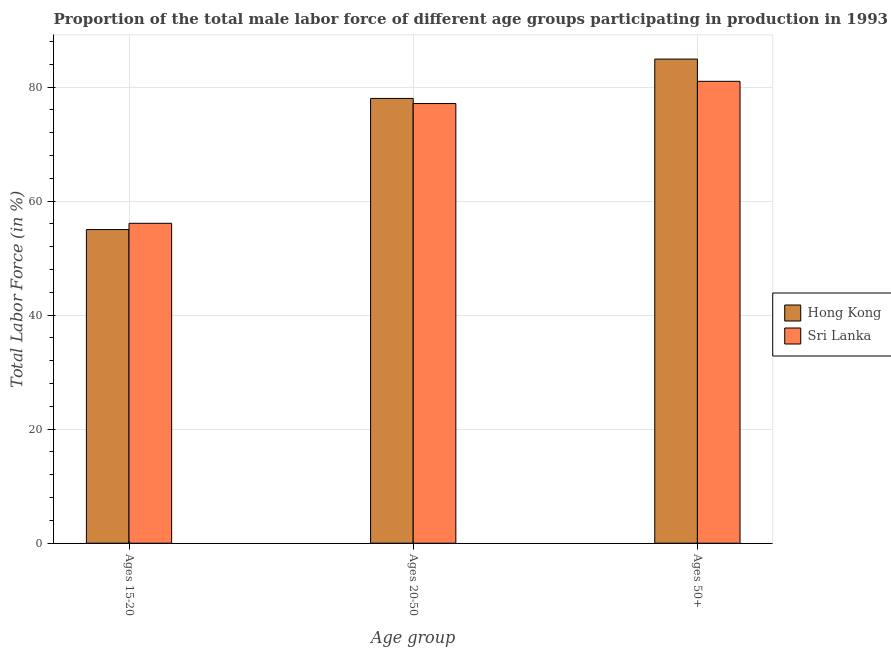How many different coloured bars are there?
Ensure brevity in your answer.  2. How many groups of bars are there?
Provide a short and direct response. 3. Are the number of bars on each tick of the X-axis equal?
Ensure brevity in your answer.  Yes. How many bars are there on the 2nd tick from the left?
Give a very brief answer. 2. What is the label of the 2nd group of bars from the left?
Your response must be concise. Ages 20-50. Across all countries, what is the maximum percentage of male labor force above age 50?
Give a very brief answer. 84.9. Across all countries, what is the minimum percentage of male labor force above age 50?
Keep it short and to the point. 81. In which country was the percentage of male labor force above age 50 maximum?
Provide a short and direct response. Hong Kong. In which country was the percentage of male labor force within the age group 20-50 minimum?
Your answer should be very brief. Sri Lanka. What is the total percentage of male labor force within the age group 15-20 in the graph?
Your answer should be compact. 111.1. What is the difference between the percentage of male labor force above age 50 in Hong Kong and that in Sri Lanka?
Your answer should be compact. 3.9. What is the difference between the percentage of male labor force above age 50 in Sri Lanka and the percentage of male labor force within the age group 15-20 in Hong Kong?
Provide a succinct answer. 26. What is the average percentage of male labor force within the age group 20-50 per country?
Your answer should be compact. 77.55. What is the difference between the percentage of male labor force above age 50 and percentage of male labor force within the age group 15-20 in Hong Kong?
Keep it short and to the point. 29.9. In how many countries, is the percentage of male labor force above age 50 greater than 64 %?
Your response must be concise. 2. What is the ratio of the percentage of male labor force within the age group 20-50 in Hong Kong to that in Sri Lanka?
Provide a succinct answer. 1.01. Is the percentage of male labor force above age 50 in Hong Kong less than that in Sri Lanka?
Your response must be concise. No. Is the difference between the percentage of male labor force above age 50 in Sri Lanka and Hong Kong greater than the difference between the percentage of male labor force within the age group 15-20 in Sri Lanka and Hong Kong?
Offer a very short reply. No. What is the difference between the highest and the second highest percentage of male labor force within the age group 20-50?
Keep it short and to the point. 0.9. What is the difference between the highest and the lowest percentage of male labor force within the age group 15-20?
Provide a short and direct response. 1.1. In how many countries, is the percentage of male labor force within the age group 15-20 greater than the average percentage of male labor force within the age group 15-20 taken over all countries?
Your response must be concise. 1. What does the 2nd bar from the left in Ages 20-50 represents?
Your answer should be very brief. Sri Lanka. What does the 1st bar from the right in Ages 50+ represents?
Keep it short and to the point. Sri Lanka. How many bars are there?
Ensure brevity in your answer.  6. How many countries are there in the graph?
Your answer should be compact. 2. Does the graph contain any zero values?
Give a very brief answer. No. Where does the legend appear in the graph?
Make the answer very short. Center right. How many legend labels are there?
Make the answer very short. 2. What is the title of the graph?
Your answer should be compact. Proportion of the total male labor force of different age groups participating in production in 1993. What is the label or title of the X-axis?
Make the answer very short. Age group. What is the label or title of the Y-axis?
Ensure brevity in your answer.  Total Labor Force (in %). What is the Total Labor Force (in %) in Hong Kong in Ages 15-20?
Your answer should be very brief. 55. What is the Total Labor Force (in %) of Sri Lanka in Ages 15-20?
Provide a short and direct response. 56.1. What is the Total Labor Force (in %) of Hong Kong in Ages 20-50?
Your answer should be compact. 78. What is the Total Labor Force (in %) in Sri Lanka in Ages 20-50?
Offer a very short reply. 77.1. What is the Total Labor Force (in %) in Hong Kong in Ages 50+?
Give a very brief answer. 84.9. What is the Total Labor Force (in %) in Sri Lanka in Ages 50+?
Provide a short and direct response. 81. Across all Age group, what is the maximum Total Labor Force (in %) of Hong Kong?
Provide a succinct answer. 84.9. Across all Age group, what is the minimum Total Labor Force (in %) of Sri Lanka?
Offer a terse response. 56.1. What is the total Total Labor Force (in %) in Hong Kong in the graph?
Offer a very short reply. 217.9. What is the total Total Labor Force (in %) of Sri Lanka in the graph?
Provide a short and direct response. 214.2. What is the difference between the Total Labor Force (in %) in Hong Kong in Ages 15-20 and that in Ages 20-50?
Give a very brief answer. -23. What is the difference between the Total Labor Force (in %) of Sri Lanka in Ages 15-20 and that in Ages 20-50?
Your answer should be very brief. -21. What is the difference between the Total Labor Force (in %) of Hong Kong in Ages 15-20 and that in Ages 50+?
Your answer should be compact. -29.9. What is the difference between the Total Labor Force (in %) of Sri Lanka in Ages 15-20 and that in Ages 50+?
Make the answer very short. -24.9. What is the difference between the Total Labor Force (in %) in Sri Lanka in Ages 20-50 and that in Ages 50+?
Provide a short and direct response. -3.9. What is the difference between the Total Labor Force (in %) of Hong Kong in Ages 15-20 and the Total Labor Force (in %) of Sri Lanka in Ages 20-50?
Your answer should be compact. -22.1. What is the average Total Labor Force (in %) in Hong Kong per Age group?
Give a very brief answer. 72.63. What is the average Total Labor Force (in %) in Sri Lanka per Age group?
Offer a terse response. 71.4. What is the difference between the Total Labor Force (in %) in Hong Kong and Total Labor Force (in %) in Sri Lanka in Ages 15-20?
Provide a succinct answer. -1.1. What is the difference between the Total Labor Force (in %) in Hong Kong and Total Labor Force (in %) in Sri Lanka in Ages 20-50?
Provide a succinct answer. 0.9. What is the ratio of the Total Labor Force (in %) of Hong Kong in Ages 15-20 to that in Ages 20-50?
Your response must be concise. 0.71. What is the ratio of the Total Labor Force (in %) of Sri Lanka in Ages 15-20 to that in Ages 20-50?
Give a very brief answer. 0.73. What is the ratio of the Total Labor Force (in %) of Hong Kong in Ages 15-20 to that in Ages 50+?
Ensure brevity in your answer.  0.65. What is the ratio of the Total Labor Force (in %) of Sri Lanka in Ages 15-20 to that in Ages 50+?
Give a very brief answer. 0.69. What is the ratio of the Total Labor Force (in %) of Hong Kong in Ages 20-50 to that in Ages 50+?
Make the answer very short. 0.92. What is the ratio of the Total Labor Force (in %) in Sri Lanka in Ages 20-50 to that in Ages 50+?
Offer a terse response. 0.95. What is the difference between the highest and the second highest Total Labor Force (in %) in Hong Kong?
Your response must be concise. 6.9. What is the difference between the highest and the second highest Total Labor Force (in %) in Sri Lanka?
Offer a very short reply. 3.9. What is the difference between the highest and the lowest Total Labor Force (in %) of Hong Kong?
Offer a terse response. 29.9. What is the difference between the highest and the lowest Total Labor Force (in %) in Sri Lanka?
Your response must be concise. 24.9. 